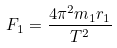Convert formula to latex. <formula><loc_0><loc_0><loc_500><loc_500>F _ { 1 } = \frac { 4 \pi ^ { 2 } m _ { 1 } r _ { 1 } } { T ^ { 2 } }</formula> 